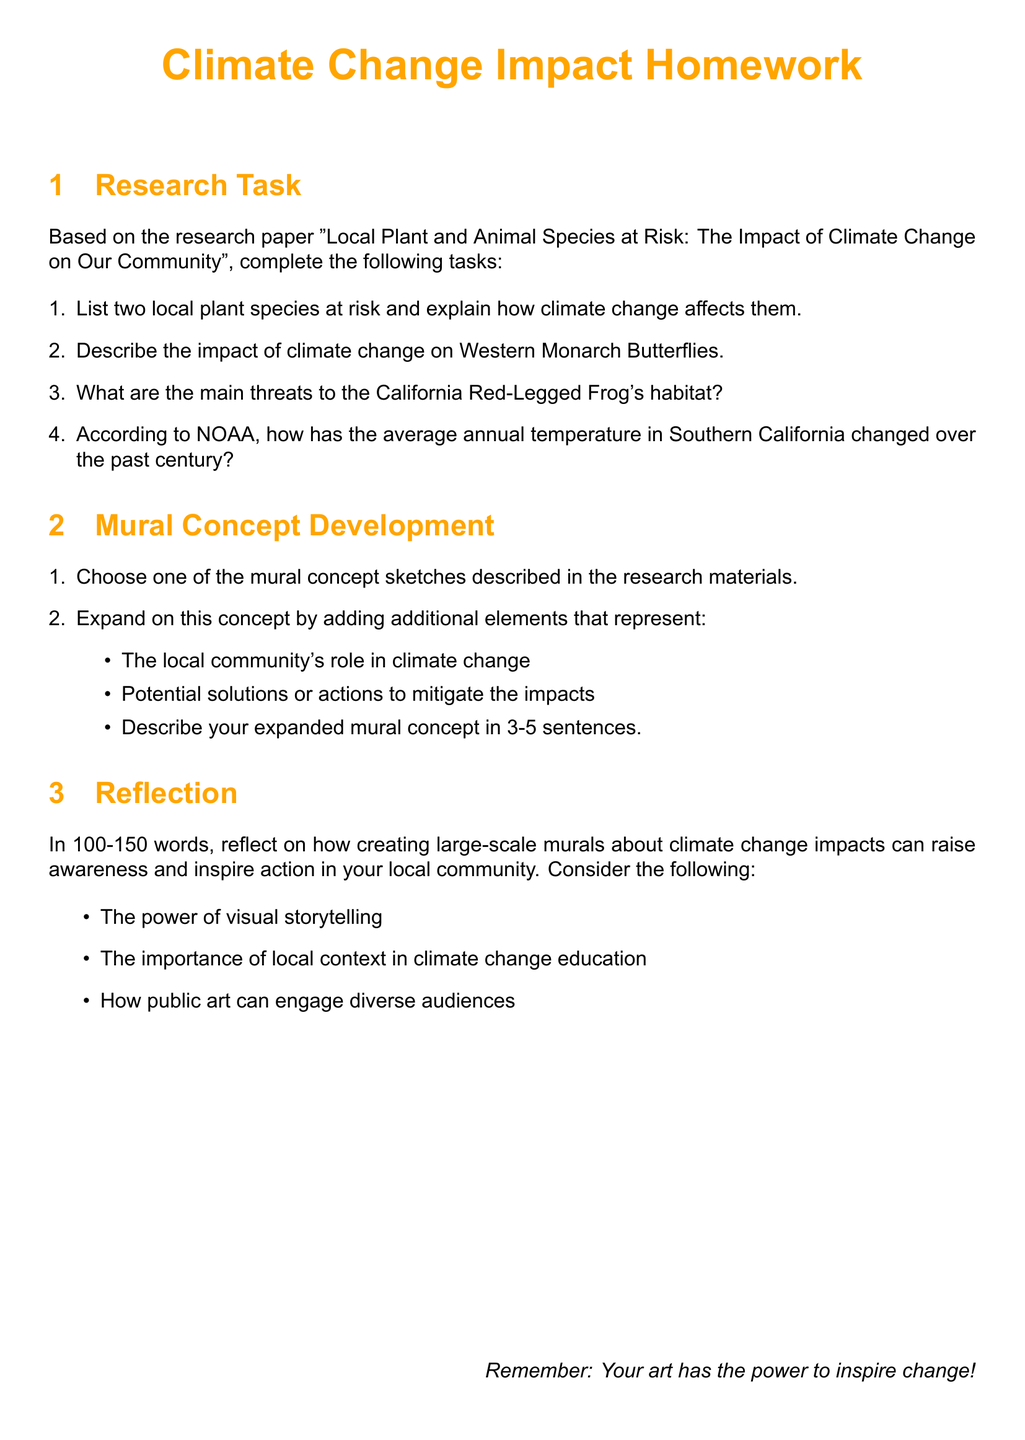What are two local plant species at risk? The document specifically mentions two local plant species at risk due to climate change.
Answer: [name of species 1, name of species 2] How does climate change affect local plant species? The document explains the specific effects of climate change on local plant species in detail.
Answer: [description of effects] What species is affected by climate change in regard to migratory patterns? The document discusses the Western Monarch Butterflies as a species impacted by climate change, particularly relating to migration.
Answer: Western Monarch Butterflies What are the main threats to the California Red-Legged Frog's habitat? The document provides information on the various threats to this frog's habitat, including various environmental and human factors.
Answer: [description of threats] What has been the change in average annual temperature in Southern California over the past century? The document outlines the specific numerical change in average temperature over the past 100 years as reported by NOAA.
Answer: [temperature change] How should the mural concept develop further? The document suggests expanding a chosen mural concept by incorporating additional elements relevant to community action and solutions.
Answer: [description of expansion] Why is visual storytelling significant in climate change awareness? The document prompts reflection on the power of visual storytelling in raising climate change awareness through public art.
Answer: [reason for significance] What is the ideal length for the reflection section? The document specifies the required word count for the reflection section of the homework assignment.
Answer: 100-150 words 